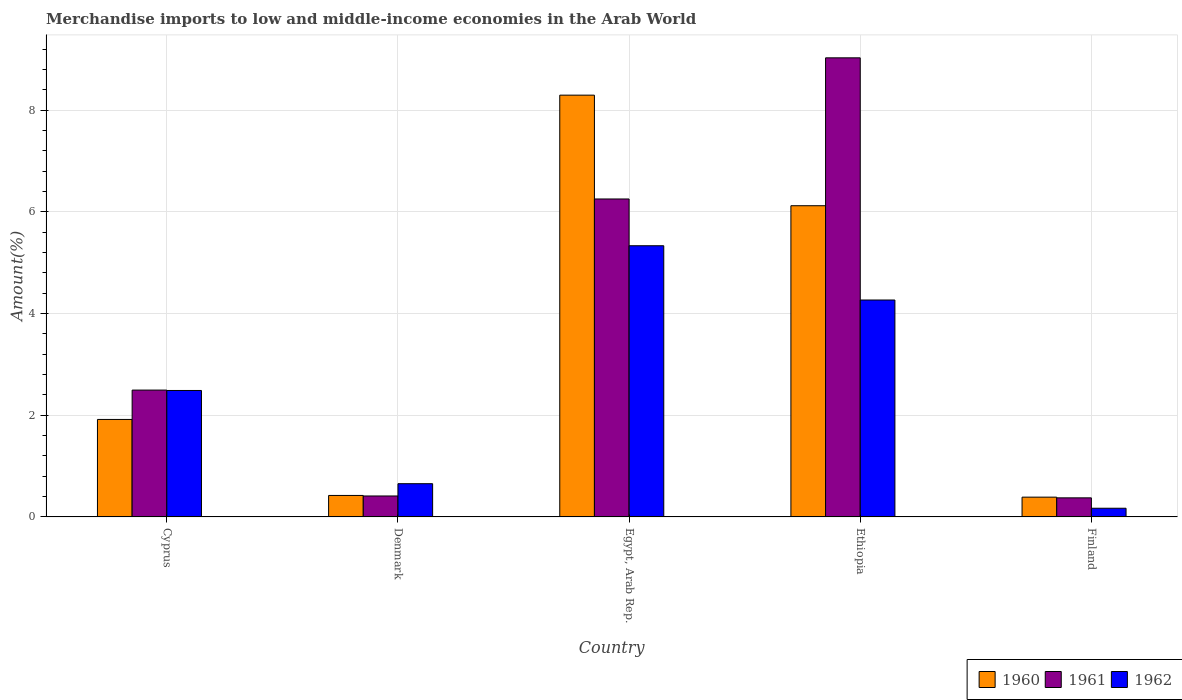How many different coloured bars are there?
Offer a very short reply. 3. How many groups of bars are there?
Keep it short and to the point. 5. Are the number of bars per tick equal to the number of legend labels?
Keep it short and to the point. Yes. How many bars are there on the 5th tick from the left?
Offer a terse response. 3. What is the label of the 5th group of bars from the left?
Your response must be concise. Finland. What is the percentage of amount earned from merchandise imports in 1962 in Ethiopia?
Provide a succinct answer. 4.27. Across all countries, what is the maximum percentage of amount earned from merchandise imports in 1962?
Make the answer very short. 5.34. Across all countries, what is the minimum percentage of amount earned from merchandise imports in 1960?
Your response must be concise. 0.39. In which country was the percentage of amount earned from merchandise imports in 1961 maximum?
Your answer should be compact. Ethiopia. In which country was the percentage of amount earned from merchandise imports in 1960 minimum?
Your response must be concise. Finland. What is the total percentage of amount earned from merchandise imports in 1962 in the graph?
Offer a very short reply. 12.92. What is the difference between the percentage of amount earned from merchandise imports in 1962 in Cyprus and that in Ethiopia?
Ensure brevity in your answer.  -1.78. What is the difference between the percentage of amount earned from merchandise imports in 1960 in Egypt, Arab Rep. and the percentage of amount earned from merchandise imports in 1962 in Ethiopia?
Make the answer very short. 4.03. What is the average percentage of amount earned from merchandise imports in 1962 per country?
Make the answer very short. 2.58. What is the difference between the percentage of amount earned from merchandise imports of/in 1960 and percentage of amount earned from merchandise imports of/in 1962 in Cyprus?
Your answer should be compact. -0.57. In how many countries, is the percentage of amount earned from merchandise imports in 1960 greater than 8.8 %?
Provide a succinct answer. 0. What is the ratio of the percentage of amount earned from merchandise imports in 1962 in Egypt, Arab Rep. to that in Finland?
Your answer should be compact. 31.19. Is the percentage of amount earned from merchandise imports in 1960 in Egypt, Arab Rep. less than that in Ethiopia?
Your response must be concise. No. What is the difference between the highest and the second highest percentage of amount earned from merchandise imports in 1960?
Provide a succinct answer. 6.38. What is the difference between the highest and the lowest percentage of amount earned from merchandise imports in 1961?
Provide a succinct answer. 8.66. In how many countries, is the percentage of amount earned from merchandise imports in 1962 greater than the average percentage of amount earned from merchandise imports in 1962 taken over all countries?
Offer a very short reply. 2. Is the sum of the percentage of amount earned from merchandise imports in 1960 in Denmark and Ethiopia greater than the maximum percentage of amount earned from merchandise imports in 1961 across all countries?
Provide a succinct answer. No. How many bars are there?
Your answer should be very brief. 15. Are all the bars in the graph horizontal?
Offer a terse response. No. How many countries are there in the graph?
Provide a succinct answer. 5. What is the difference between two consecutive major ticks on the Y-axis?
Your response must be concise. 2. Where does the legend appear in the graph?
Provide a short and direct response. Bottom right. How many legend labels are there?
Offer a terse response. 3. How are the legend labels stacked?
Offer a very short reply. Horizontal. What is the title of the graph?
Offer a very short reply. Merchandise imports to low and middle-income economies in the Arab World. Does "2002" appear as one of the legend labels in the graph?
Give a very brief answer. No. What is the label or title of the X-axis?
Provide a short and direct response. Country. What is the label or title of the Y-axis?
Ensure brevity in your answer.  Amount(%). What is the Amount(%) of 1960 in Cyprus?
Your answer should be compact. 1.92. What is the Amount(%) in 1961 in Cyprus?
Your answer should be compact. 2.5. What is the Amount(%) in 1962 in Cyprus?
Keep it short and to the point. 2.49. What is the Amount(%) of 1960 in Denmark?
Give a very brief answer. 0.42. What is the Amount(%) of 1961 in Denmark?
Give a very brief answer. 0.41. What is the Amount(%) of 1962 in Denmark?
Offer a very short reply. 0.65. What is the Amount(%) in 1960 in Egypt, Arab Rep.?
Provide a short and direct response. 8.3. What is the Amount(%) of 1961 in Egypt, Arab Rep.?
Your answer should be very brief. 6.26. What is the Amount(%) of 1962 in Egypt, Arab Rep.?
Give a very brief answer. 5.34. What is the Amount(%) in 1960 in Ethiopia?
Offer a very short reply. 6.12. What is the Amount(%) of 1961 in Ethiopia?
Offer a very short reply. 9.03. What is the Amount(%) of 1962 in Ethiopia?
Make the answer very short. 4.27. What is the Amount(%) in 1960 in Finland?
Keep it short and to the point. 0.39. What is the Amount(%) of 1961 in Finland?
Offer a terse response. 0.38. What is the Amount(%) of 1962 in Finland?
Provide a short and direct response. 0.17. Across all countries, what is the maximum Amount(%) in 1960?
Give a very brief answer. 8.3. Across all countries, what is the maximum Amount(%) of 1961?
Ensure brevity in your answer.  9.03. Across all countries, what is the maximum Amount(%) in 1962?
Make the answer very short. 5.34. Across all countries, what is the minimum Amount(%) in 1960?
Offer a terse response. 0.39. Across all countries, what is the minimum Amount(%) in 1961?
Give a very brief answer. 0.38. Across all countries, what is the minimum Amount(%) in 1962?
Offer a very short reply. 0.17. What is the total Amount(%) in 1960 in the graph?
Your answer should be very brief. 17.15. What is the total Amount(%) of 1961 in the graph?
Ensure brevity in your answer.  18.57. What is the total Amount(%) of 1962 in the graph?
Make the answer very short. 12.92. What is the difference between the Amount(%) of 1960 in Cyprus and that in Denmark?
Make the answer very short. 1.5. What is the difference between the Amount(%) of 1961 in Cyprus and that in Denmark?
Your response must be concise. 2.08. What is the difference between the Amount(%) of 1962 in Cyprus and that in Denmark?
Ensure brevity in your answer.  1.83. What is the difference between the Amount(%) in 1960 in Cyprus and that in Egypt, Arab Rep.?
Your response must be concise. -6.38. What is the difference between the Amount(%) of 1961 in Cyprus and that in Egypt, Arab Rep.?
Keep it short and to the point. -3.76. What is the difference between the Amount(%) in 1962 in Cyprus and that in Egypt, Arab Rep.?
Your response must be concise. -2.85. What is the difference between the Amount(%) in 1960 in Cyprus and that in Ethiopia?
Keep it short and to the point. -4.2. What is the difference between the Amount(%) of 1961 in Cyprus and that in Ethiopia?
Your response must be concise. -6.54. What is the difference between the Amount(%) in 1962 in Cyprus and that in Ethiopia?
Your answer should be very brief. -1.78. What is the difference between the Amount(%) in 1960 in Cyprus and that in Finland?
Your answer should be very brief. 1.53. What is the difference between the Amount(%) in 1961 in Cyprus and that in Finland?
Your answer should be very brief. 2.12. What is the difference between the Amount(%) in 1962 in Cyprus and that in Finland?
Offer a very short reply. 2.32. What is the difference between the Amount(%) in 1960 in Denmark and that in Egypt, Arab Rep.?
Give a very brief answer. -7.88. What is the difference between the Amount(%) in 1961 in Denmark and that in Egypt, Arab Rep.?
Your response must be concise. -5.84. What is the difference between the Amount(%) in 1962 in Denmark and that in Egypt, Arab Rep.?
Your answer should be very brief. -4.68. What is the difference between the Amount(%) in 1960 in Denmark and that in Ethiopia?
Offer a very short reply. -5.7. What is the difference between the Amount(%) of 1961 in Denmark and that in Ethiopia?
Your response must be concise. -8.62. What is the difference between the Amount(%) in 1962 in Denmark and that in Ethiopia?
Give a very brief answer. -3.61. What is the difference between the Amount(%) in 1960 in Denmark and that in Finland?
Make the answer very short. 0.03. What is the difference between the Amount(%) of 1961 in Denmark and that in Finland?
Offer a very short reply. 0.04. What is the difference between the Amount(%) in 1962 in Denmark and that in Finland?
Provide a succinct answer. 0.48. What is the difference between the Amount(%) of 1960 in Egypt, Arab Rep. and that in Ethiopia?
Keep it short and to the point. 2.18. What is the difference between the Amount(%) of 1961 in Egypt, Arab Rep. and that in Ethiopia?
Make the answer very short. -2.78. What is the difference between the Amount(%) in 1962 in Egypt, Arab Rep. and that in Ethiopia?
Give a very brief answer. 1.07. What is the difference between the Amount(%) of 1960 in Egypt, Arab Rep. and that in Finland?
Offer a very short reply. 7.91. What is the difference between the Amount(%) of 1961 in Egypt, Arab Rep. and that in Finland?
Give a very brief answer. 5.88. What is the difference between the Amount(%) of 1962 in Egypt, Arab Rep. and that in Finland?
Your response must be concise. 5.16. What is the difference between the Amount(%) in 1960 in Ethiopia and that in Finland?
Offer a very short reply. 5.73. What is the difference between the Amount(%) in 1961 in Ethiopia and that in Finland?
Make the answer very short. 8.66. What is the difference between the Amount(%) in 1962 in Ethiopia and that in Finland?
Ensure brevity in your answer.  4.1. What is the difference between the Amount(%) of 1960 in Cyprus and the Amount(%) of 1961 in Denmark?
Offer a very short reply. 1.51. What is the difference between the Amount(%) in 1960 in Cyprus and the Amount(%) in 1962 in Denmark?
Provide a short and direct response. 1.26. What is the difference between the Amount(%) of 1961 in Cyprus and the Amount(%) of 1962 in Denmark?
Offer a very short reply. 1.84. What is the difference between the Amount(%) in 1960 in Cyprus and the Amount(%) in 1961 in Egypt, Arab Rep.?
Provide a succinct answer. -4.34. What is the difference between the Amount(%) of 1960 in Cyprus and the Amount(%) of 1962 in Egypt, Arab Rep.?
Offer a terse response. -3.42. What is the difference between the Amount(%) of 1961 in Cyprus and the Amount(%) of 1962 in Egypt, Arab Rep.?
Provide a short and direct response. -2.84. What is the difference between the Amount(%) in 1960 in Cyprus and the Amount(%) in 1961 in Ethiopia?
Your answer should be compact. -7.11. What is the difference between the Amount(%) in 1960 in Cyprus and the Amount(%) in 1962 in Ethiopia?
Offer a terse response. -2.35. What is the difference between the Amount(%) of 1961 in Cyprus and the Amount(%) of 1962 in Ethiopia?
Provide a succinct answer. -1.77. What is the difference between the Amount(%) of 1960 in Cyprus and the Amount(%) of 1961 in Finland?
Keep it short and to the point. 1.54. What is the difference between the Amount(%) in 1960 in Cyprus and the Amount(%) in 1962 in Finland?
Offer a terse response. 1.75. What is the difference between the Amount(%) of 1961 in Cyprus and the Amount(%) of 1962 in Finland?
Offer a terse response. 2.32. What is the difference between the Amount(%) in 1960 in Denmark and the Amount(%) in 1961 in Egypt, Arab Rep.?
Your answer should be compact. -5.83. What is the difference between the Amount(%) of 1960 in Denmark and the Amount(%) of 1962 in Egypt, Arab Rep.?
Your answer should be very brief. -4.91. What is the difference between the Amount(%) of 1961 in Denmark and the Amount(%) of 1962 in Egypt, Arab Rep.?
Your answer should be very brief. -4.92. What is the difference between the Amount(%) of 1960 in Denmark and the Amount(%) of 1961 in Ethiopia?
Your answer should be very brief. -8.61. What is the difference between the Amount(%) of 1960 in Denmark and the Amount(%) of 1962 in Ethiopia?
Your answer should be compact. -3.84. What is the difference between the Amount(%) in 1961 in Denmark and the Amount(%) in 1962 in Ethiopia?
Ensure brevity in your answer.  -3.86. What is the difference between the Amount(%) of 1960 in Denmark and the Amount(%) of 1961 in Finland?
Your answer should be very brief. 0.05. What is the difference between the Amount(%) of 1960 in Denmark and the Amount(%) of 1962 in Finland?
Provide a succinct answer. 0.25. What is the difference between the Amount(%) of 1961 in Denmark and the Amount(%) of 1962 in Finland?
Ensure brevity in your answer.  0.24. What is the difference between the Amount(%) of 1960 in Egypt, Arab Rep. and the Amount(%) of 1961 in Ethiopia?
Give a very brief answer. -0.73. What is the difference between the Amount(%) of 1960 in Egypt, Arab Rep. and the Amount(%) of 1962 in Ethiopia?
Offer a very short reply. 4.03. What is the difference between the Amount(%) of 1961 in Egypt, Arab Rep. and the Amount(%) of 1962 in Ethiopia?
Your answer should be very brief. 1.99. What is the difference between the Amount(%) of 1960 in Egypt, Arab Rep. and the Amount(%) of 1961 in Finland?
Make the answer very short. 7.92. What is the difference between the Amount(%) in 1960 in Egypt, Arab Rep. and the Amount(%) in 1962 in Finland?
Your response must be concise. 8.13. What is the difference between the Amount(%) of 1961 in Egypt, Arab Rep. and the Amount(%) of 1962 in Finland?
Provide a succinct answer. 6.08. What is the difference between the Amount(%) of 1960 in Ethiopia and the Amount(%) of 1961 in Finland?
Offer a very short reply. 5.75. What is the difference between the Amount(%) in 1960 in Ethiopia and the Amount(%) in 1962 in Finland?
Provide a succinct answer. 5.95. What is the difference between the Amount(%) of 1961 in Ethiopia and the Amount(%) of 1962 in Finland?
Your response must be concise. 8.86. What is the average Amount(%) of 1960 per country?
Your response must be concise. 3.43. What is the average Amount(%) of 1961 per country?
Your answer should be very brief. 3.71. What is the average Amount(%) in 1962 per country?
Your response must be concise. 2.58. What is the difference between the Amount(%) of 1960 and Amount(%) of 1961 in Cyprus?
Give a very brief answer. -0.58. What is the difference between the Amount(%) of 1960 and Amount(%) of 1962 in Cyprus?
Keep it short and to the point. -0.57. What is the difference between the Amount(%) of 1961 and Amount(%) of 1962 in Cyprus?
Your response must be concise. 0.01. What is the difference between the Amount(%) of 1960 and Amount(%) of 1961 in Denmark?
Keep it short and to the point. 0.01. What is the difference between the Amount(%) of 1960 and Amount(%) of 1962 in Denmark?
Your answer should be very brief. -0.23. What is the difference between the Amount(%) in 1961 and Amount(%) in 1962 in Denmark?
Provide a short and direct response. -0.24. What is the difference between the Amount(%) of 1960 and Amount(%) of 1961 in Egypt, Arab Rep.?
Provide a succinct answer. 2.04. What is the difference between the Amount(%) of 1960 and Amount(%) of 1962 in Egypt, Arab Rep.?
Ensure brevity in your answer.  2.96. What is the difference between the Amount(%) in 1961 and Amount(%) in 1962 in Egypt, Arab Rep.?
Give a very brief answer. 0.92. What is the difference between the Amount(%) in 1960 and Amount(%) in 1961 in Ethiopia?
Your answer should be very brief. -2.91. What is the difference between the Amount(%) in 1960 and Amount(%) in 1962 in Ethiopia?
Make the answer very short. 1.85. What is the difference between the Amount(%) of 1961 and Amount(%) of 1962 in Ethiopia?
Make the answer very short. 4.76. What is the difference between the Amount(%) in 1960 and Amount(%) in 1961 in Finland?
Your answer should be very brief. 0.01. What is the difference between the Amount(%) in 1960 and Amount(%) in 1962 in Finland?
Provide a short and direct response. 0.22. What is the difference between the Amount(%) of 1961 and Amount(%) of 1962 in Finland?
Make the answer very short. 0.2. What is the ratio of the Amount(%) in 1960 in Cyprus to that in Denmark?
Your response must be concise. 4.54. What is the ratio of the Amount(%) of 1961 in Cyprus to that in Denmark?
Ensure brevity in your answer.  6.05. What is the ratio of the Amount(%) in 1962 in Cyprus to that in Denmark?
Make the answer very short. 3.8. What is the ratio of the Amount(%) in 1960 in Cyprus to that in Egypt, Arab Rep.?
Provide a succinct answer. 0.23. What is the ratio of the Amount(%) in 1961 in Cyprus to that in Egypt, Arab Rep.?
Keep it short and to the point. 0.4. What is the ratio of the Amount(%) of 1962 in Cyprus to that in Egypt, Arab Rep.?
Offer a very short reply. 0.47. What is the ratio of the Amount(%) in 1960 in Cyprus to that in Ethiopia?
Keep it short and to the point. 0.31. What is the ratio of the Amount(%) in 1961 in Cyprus to that in Ethiopia?
Your answer should be very brief. 0.28. What is the ratio of the Amount(%) in 1962 in Cyprus to that in Ethiopia?
Give a very brief answer. 0.58. What is the ratio of the Amount(%) of 1960 in Cyprus to that in Finland?
Your response must be concise. 4.93. What is the ratio of the Amount(%) in 1961 in Cyprus to that in Finland?
Your answer should be very brief. 6.65. What is the ratio of the Amount(%) of 1962 in Cyprus to that in Finland?
Offer a terse response. 14.55. What is the ratio of the Amount(%) of 1960 in Denmark to that in Egypt, Arab Rep.?
Give a very brief answer. 0.05. What is the ratio of the Amount(%) in 1961 in Denmark to that in Egypt, Arab Rep.?
Offer a terse response. 0.07. What is the ratio of the Amount(%) in 1962 in Denmark to that in Egypt, Arab Rep.?
Provide a short and direct response. 0.12. What is the ratio of the Amount(%) of 1960 in Denmark to that in Ethiopia?
Your answer should be compact. 0.07. What is the ratio of the Amount(%) in 1961 in Denmark to that in Ethiopia?
Your answer should be very brief. 0.05. What is the ratio of the Amount(%) in 1962 in Denmark to that in Ethiopia?
Give a very brief answer. 0.15. What is the ratio of the Amount(%) in 1960 in Denmark to that in Finland?
Offer a terse response. 1.09. What is the ratio of the Amount(%) in 1961 in Denmark to that in Finland?
Offer a terse response. 1.1. What is the ratio of the Amount(%) of 1962 in Denmark to that in Finland?
Keep it short and to the point. 3.82. What is the ratio of the Amount(%) in 1960 in Egypt, Arab Rep. to that in Ethiopia?
Ensure brevity in your answer.  1.36. What is the ratio of the Amount(%) of 1961 in Egypt, Arab Rep. to that in Ethiopia?
Your answer should be very brief. 0.69. What is the ratio of the Amount(%) in 1962 in Egypt, Arab Rep. to that in Ethiopia?
Your answer should be compact. 1.25. What is the ratio of the Amount(%) in 1960 in Egypt, Arab Rep. to that in Finland?
Offer a terse response. 21.33. What is the ratio of the Amount(%) in 1961 in Egypt, Arab Rep. to that in Finland?
Offer a terse response. 16.67. What is the ratio of the Amount(%) of 1962 in Egypt, Arab Rep. to that in Finland?
Keep it short and to the point. 31.19. What is the ratio of the Amount(%) in 1960 in Ethiopia to that in Finland?
Offer a very short reply. 15.74. What is the ratio of the Amount(%) in 1961 in Ethiopia to that in Finland?
Offer a terse response. 24.07. What is the ratio of the Amount(%) of 1962 in Ethiopia to that in Finland?
Offer a terse response. 24.95. What is the difference between the highest and the second highest Amount(%) of 1960?
Keep it short and to the point. 2.18. What is the difference between the highest and the second highest Amount(%) of 1961?
Provide a short and direct response. 2.78. What is the difference between the highest and the second highest Amount(%) in 1962?
Keep it short and to the point. 1.07. What is the difference between the highest and the lowest Amount(%) of 1960?
Offer a very short reply. 7.91. What is the difference between the highest and the lowest Amount(%) in 1961?
Provide a succinct answer. 8.66. What is the difference between the highest and the lowest Amount(%) in 1962?
Your answer should be very brief. 5.16. 